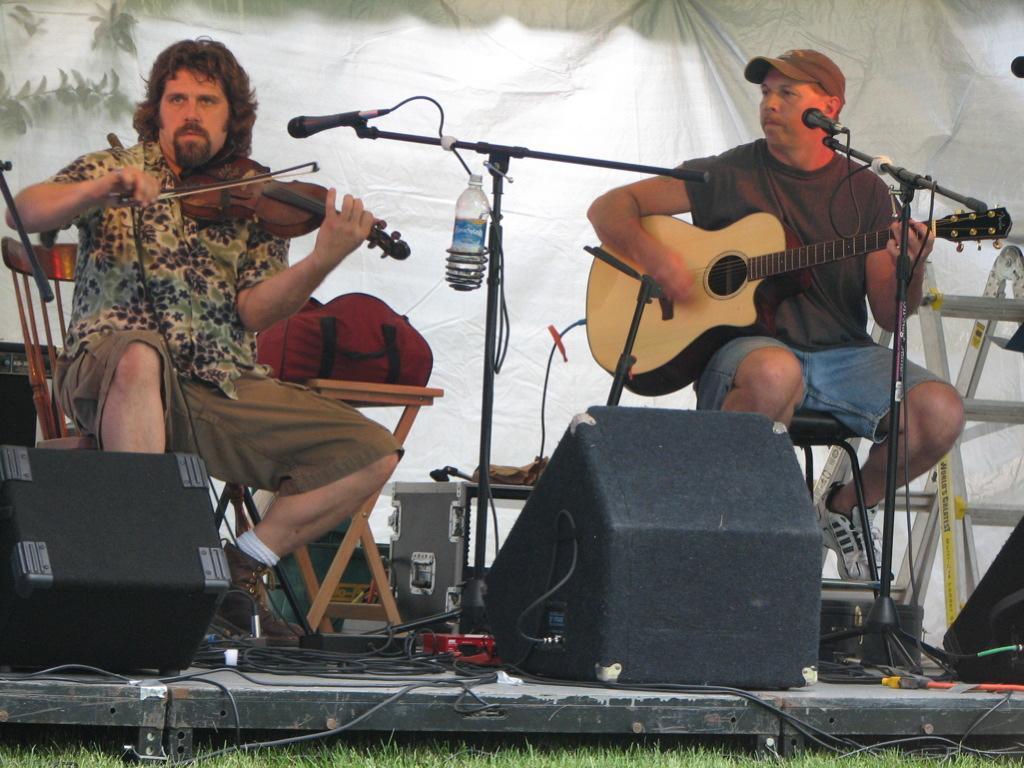Could you give a brief overview of what you see in this image? In this picture we can see two persons are playing guitar. This is mike and there is a bottle. And these are some musical instruments. On the background there is a cloth. 